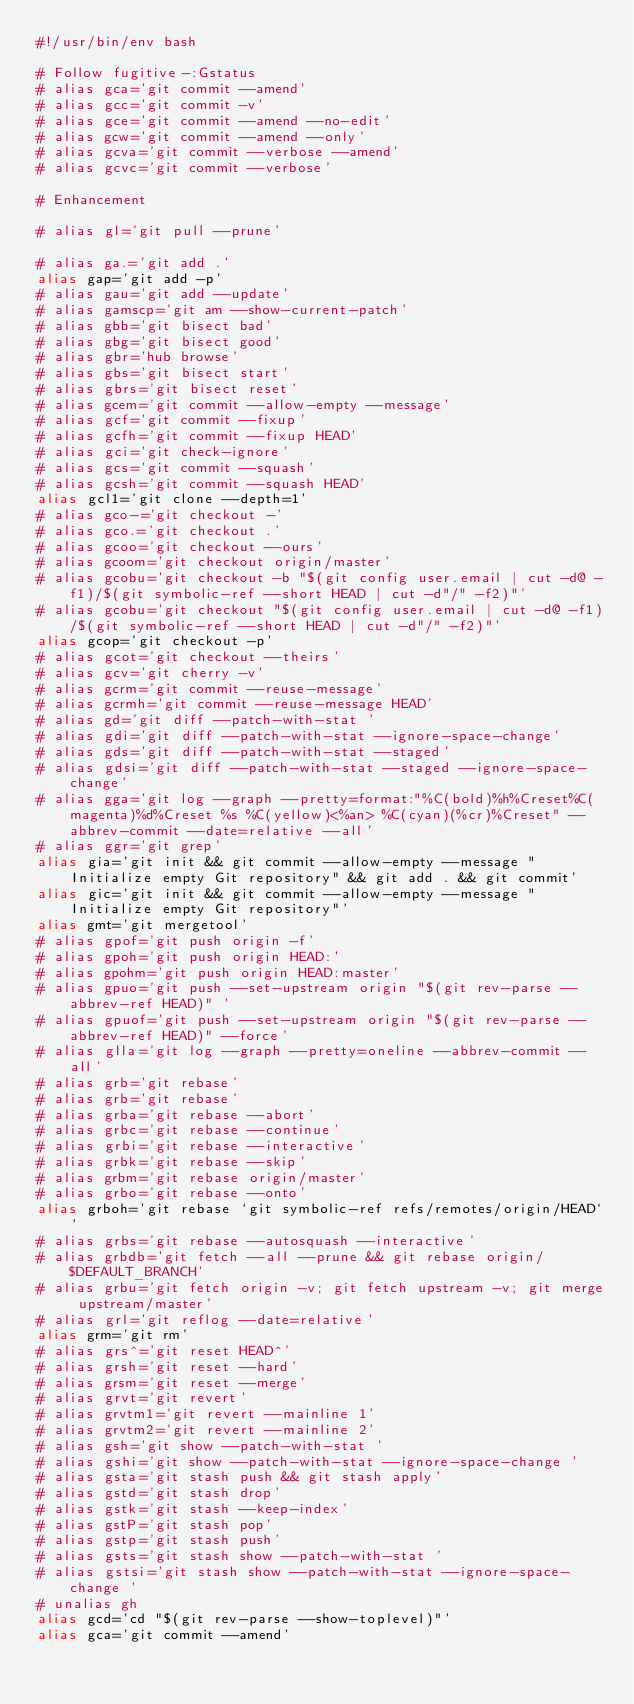<code> <loc_0><loc_0><loc_500><loc_500><_Bash_>#!/usr/bin/env bash

# Follow fugitive-:Gstatus
# alias gca='git commit --amend'
# alias gcc='git commit -v'
# alias gce='git commit --amend --no-edit'
# alias gcw='git commit --amend --only'
# alias gcva='git commit --verbose --amend'
# alias gcvc='git commit --verbose'

# Enhancement

# alias gl='git pull --prune'

# alias ga.='git add .'
alias gap='git add -p'
# alias gau='git add --update'
# alias gamscp='git am --show-current-patch'
# alias gbb='git bisect bad'
# alias gbg='git bisect good'
# alias gbr='hub browse'
# alias gbs='git bisect start'
# alias gbrs='git bisect reset'
# alias gcem='git commit --allow-empty --message'
# alias gcf='git commit --fixup'
# alias gcfh='git commit --fixup HEAD'
# alias gci='git check-ignore'
# alias gcs='git commit --squash'
# alias gcsh='git commit --squash HEAD'
alias gcl1='git clone --depth=1'
# alias gco-='git checkout -'
# alias gco.='git checkout .'
# alias gcoo='git checkout --ours'
# alias gcoom='git checkout origin/master'
# alias gcobu='git checkout -b "$(git config user.email | cut -d@ -f1)/$(git symbolic-ref --short HEAD | cut -d"/" -f2)"'
# alias gcobu='git checkout "$(git config user.email | cut -d@ -f1)/$(git symbolic-ref --short HEAD | cut -d"/" -f2)"'
alias gcop='git checkout -p'
# alias gcot='git checkout --theirs'
# alias gcv='git cherry -v'
# alias gcrm='git commit --reuse-message'
# alias gcrmh='git commit --reuse-message HEAD'
# alias gd='git diff --patch-with-stat '
# alias gdi='git diff --patch-with-stat --ignore-space-change'
# alias gds='git diff --patch-with-stat --staged'
# alias gdsi='git diff --patch-with-stat --staged --ignore-space-change'
# alias gga='git log --graph --pretty=format:"%C(bold)%h%Creset%C(magenta)%d%Creset %s %C(yellow)<%an> %C(cyan)(%cr)%Creset" --abbrev-commit --date=relative --all'
# alias ggr='git grep'
alias gia='git init && git commit --allow-empty --message "Initialize empty Git repository" && git add . && git commit'
alias gic='git init && git commit --allow-empty --message "Initialize empty Git repository"'
alias gmt='git mergetool'
# alias gpof='git push origin -f'
# alias gpoh='git push origin HEAD:'
# alias gpohm='git push origin HEAD:master'
# alias gpuo='git push --set-upstream origin "$(git rev-parse --abbrev-ref HEAD)" '
# alias gpuof='git push --set-upstream origin "$(git rev-parse --abbrev-ref HEAD)" --force'
# alias glla='git log --graph --pretty=oneline --abbrev-commit --all'
# alias grb='git rebase'
# alias grb='git rebase'
# alias grba='git rebase --abort'
# alias grbc='git rebase --continue'
# alias grbi='git rebase --interactive'
# alias grbk='git rebase --skip'
# alias grbm='git rebase origin/master'
# alias grbo='git rebase --onto'
alias grboh='git rebase `git symbolic-ref refs/remotes/origin/HEAD`'
# alias grbs='git rebase --autosquash --interactive'
# alias grbdb='git fetch --all --prune && git rebase origin/$DEFAULT_BRANCH'
# alias grbu='git fetch origin -v; git fetch upstream -v; git merge upstream/master'
# alias grl='git reflog --date=relative'
alias grm='git rm'
# alias grs^='git reset HEAD^'
# alias grsh='git reset --hard'
# alias grsm='git reset --merge'
# alias grvt='git revert'
# alias grvtm1='git revert --mainline 1'
# alias grvtm2='git revert --mainline 2'
# alias gsh='git show --patch-with-stat '
# alias gshi='git show --patch-with-stat --ignore-space-change '
# alias gsta='git stash push && git stash apply'
# alias gstd='git stash drop'
# alias gstk='git stash --keep-index'
# alias gstP='git stash pop'
# alias gstp='git stash push'
# alias gsts='git stash show --patch-with-stat '
# alias gstsi='git stash show --patch-with-stat --ignore-space-change '
# unalias gh
alias gcd='cd "$(git rev-parse --show-toplevel)"'
alias gca='git commit --amend'
</code> 